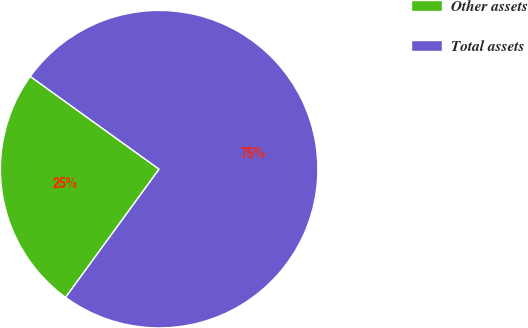Convert chart. <chart><loc_0><loc_0><loc_500><loc_500><pie_chart><fcel>Other assets<fcel>Total assets<nl><fcel>24.9%<fcel>75.1%<nl></chart> 